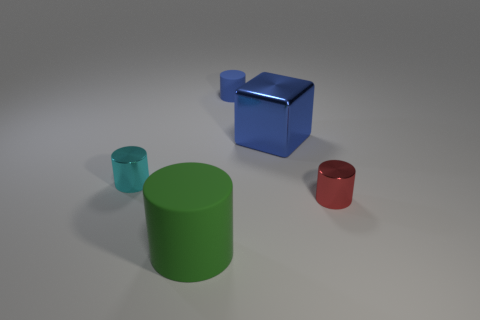What is the light source in this scene? The scene is evenly lit with what appears to be a diffused, artificial light source, potentially from above, as indicated by the soft shadows directly under the objects, suggesting a studio lighting setup. 